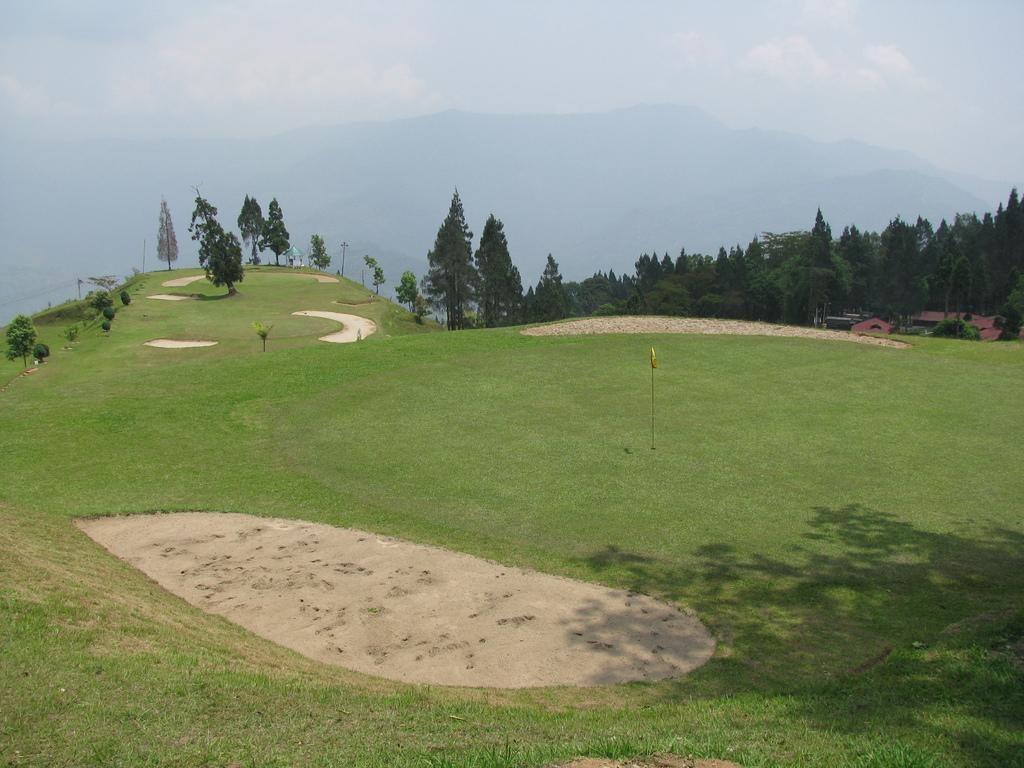What type of surface is visible in the image? There is a ground in the image. What type of vegetation can be seen in the image? There are trees in the image. What type of structures are present in the image? There are houses in the image. What type of natural formation is visible in the image? There are mountains in the image. What is visible above the ground and structures in the image? The sky is visible in the image. What historical event is being depicted in the image? There is no historical event being depicted in the image; it features a ground, trees, houses, mountains, and sky. What is the number of trees visible in the image? The number of trees visible in the image cannot be determined definitively from the provided facts. 